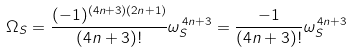<formula> <loc_0><loc_0><loc_500><loc_500>\Omega _ { S } = \frac { ( - 1 ) ^ { ( 4 n + 3 ) ( 2 n + 1 ) } } { ( 4 n + 3 ) ! } \omega _ { S } ^ { \, 4 n + 3 } = \frac { - 1 } { ( 4 n + 3 ) ! } \omega _ { S } ^ { \, 4 n + 3 }</formula> 